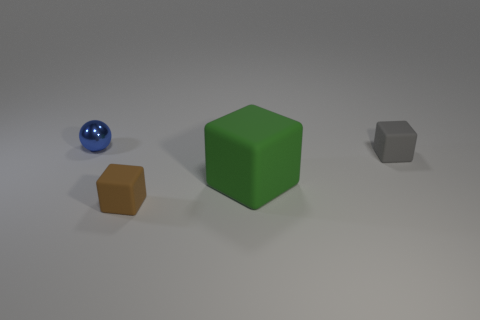Subtract all tiny blocks. How many blocks are left? 1 Subtract all brown cubes. How many cubes are left? 2 Subtract all cubes. How many objects are left? 1 Add 4 green cubes. How many objects exist? 8 Add 2 small green metallic cylinders. How many small green metallic cylinders exist? 2 Subtract 0 cyan balls. How many objects are left? 4 Subtract all green cubes. Subtract all green balls. How many cubes are left? 2 Subtract all red blocks. How many cyan spheres are left? 0 Subtract all cyan matte cylinders. Subtract all small brown rubber things. How many objects are left? 3 Add 3 small gray matte things. How many small gray matte things are left? 4 